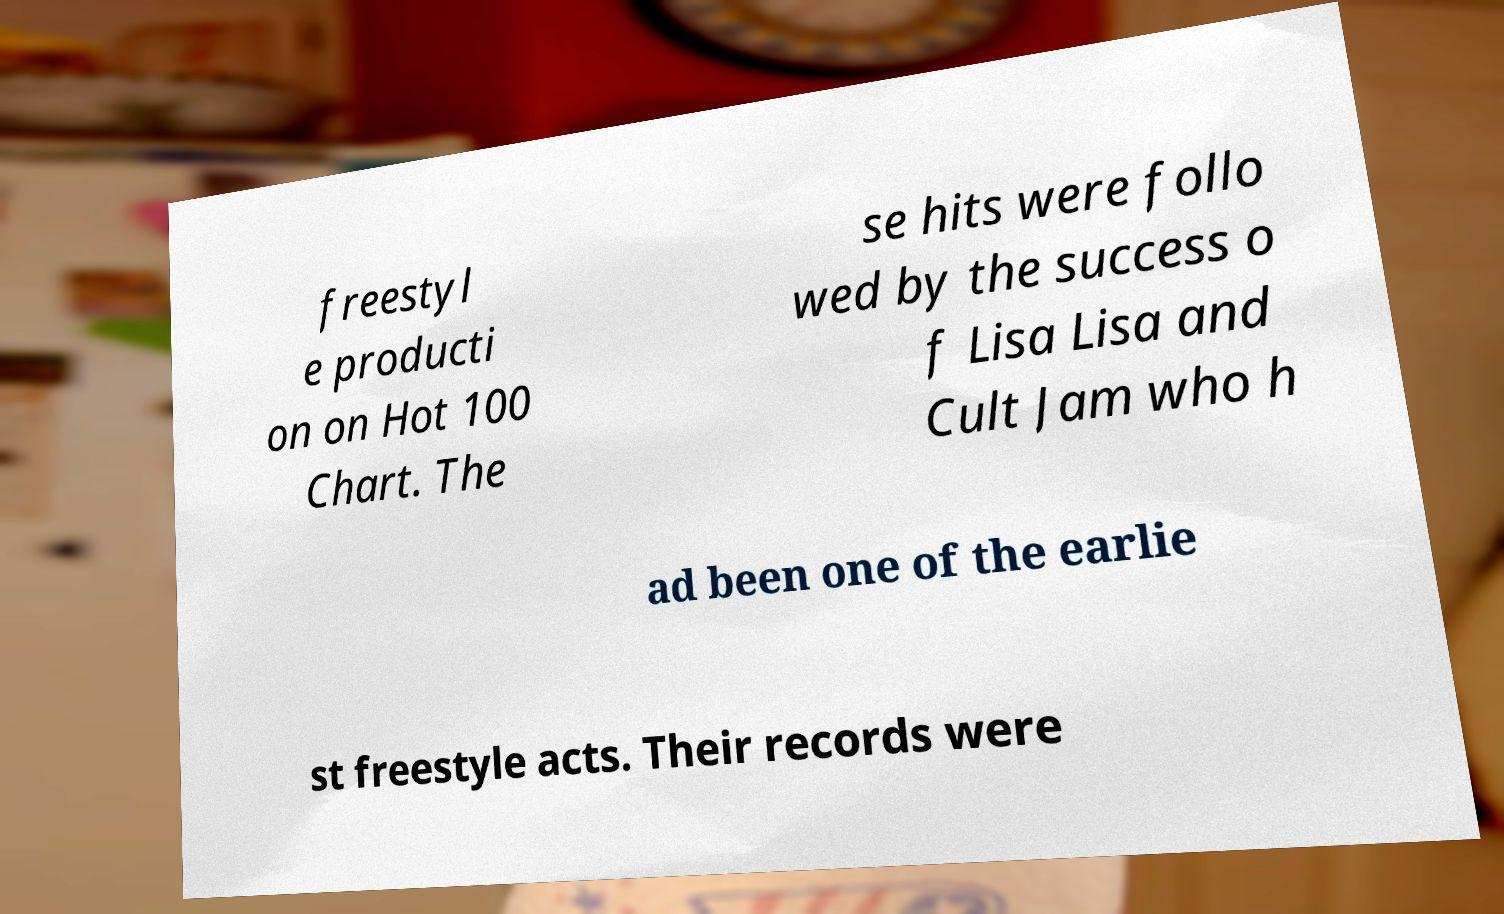Please read and relay the text visible in this image. What does it say? freestyl e producti on on Hot 100 Chart. The se hits were follo wed by the success o f Lisa Lisa and Cult Jam who h ad been one of the earlie st freestyle acts. Their records were 